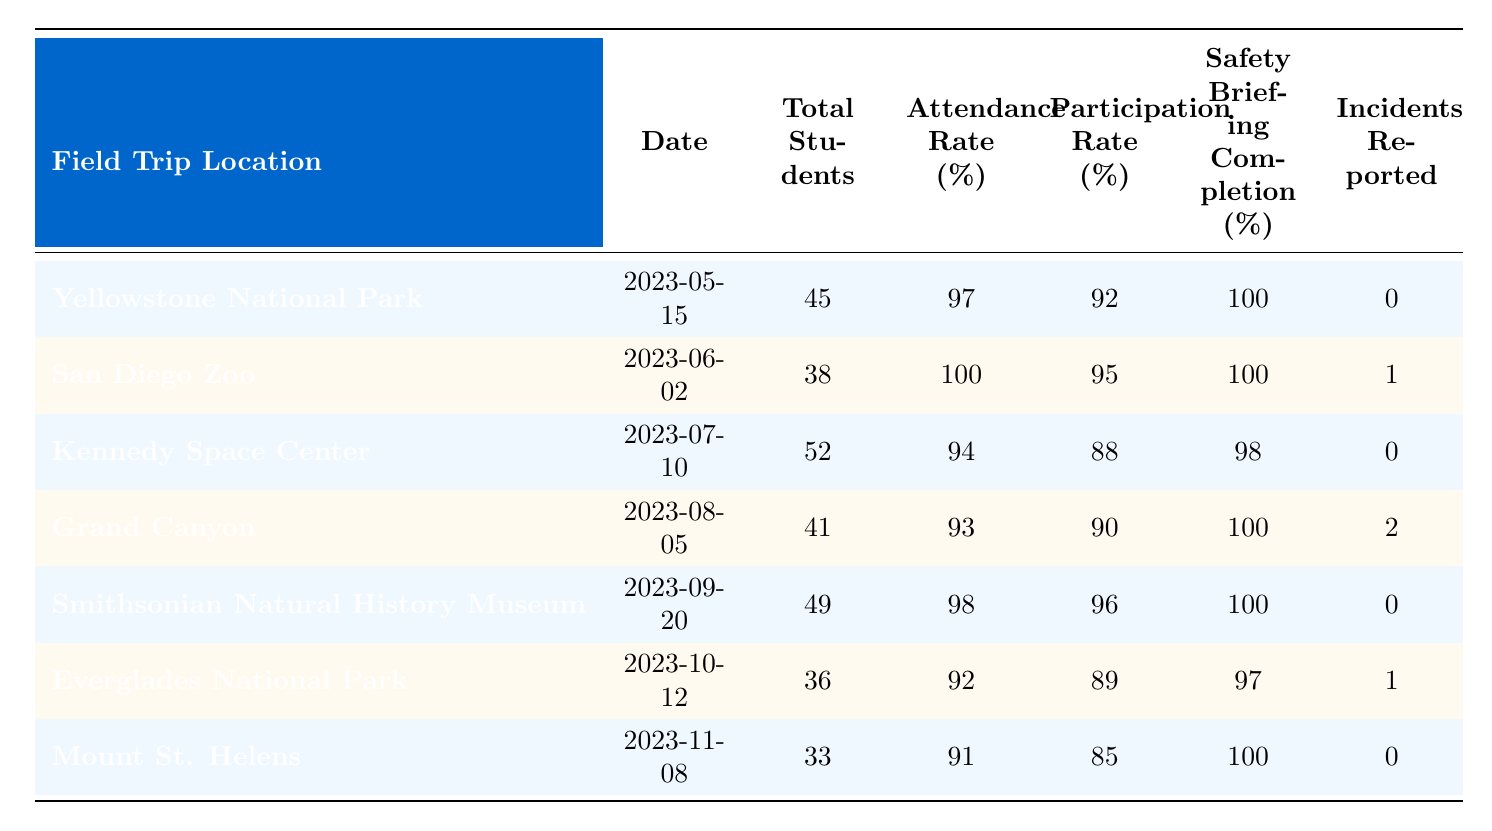What was the attendance rate for the San Diego Zoo trip? The attendance rate for the San Diego Zoo trip can be found in the table under the "Attendance Rate (%)" column for the date "2023-06-02." The value is 100%.
Answer: 100% How many incidents were reported during the Grand Canyon field trip? The number of incidents reported during the Grand Canyon field trip is listed in the "Incidents Reported" column for the date "2023-08-05." The value is 2.
Answer: 2 What is the average participation rate for all field trips? To find the average participation rate, sum all participation rates (92 + 95 + 88 + 90 + 96 + 89 + 85 = 625) and divide by the total number of trips (7). Therefore, 625/7 = approximately 89.29.
Answer: 89.29 Did all students complete the safety briefing at Yellowstone National Park? The safety briefing completion percentage for Yellowstone National Park is 100%, which indicates that all students completed the briefing.
Answer: Yes Which field trip had the lowest attendance rate? By comparing the attendance rates from each trip (97, 100, 94, 93, 98, 92, 91), the lowest attendance rate is for the Everglades National Park at 92%.
Answer: 92% How many total students attended field trips that had an incident reported? The trips with incidents reported are the San Diego Zoo (38 students) and the Grand Canyon (41 students). The total is 38 + 41 = 79.
Answer: 79 What was the safety briefing completion percentage for the Kennedy Space Center trip? The safety briefing completion percentage for the Kennedy Space Center on "2023-07-10" is found in the corresponding column, which is 98%.
Answer: 98% Which field trip had the highest number of total students? The highest number of total students is listed for the Kennedy Space Center, with 52 students, which is more than any other trip.
Answer: 52 What is the difference in attendance rates between the lowest and highest recorded rates? The highest attendance rate is 100% (San Diego Zoo) and the lowest is 91% (Mount St. Helens). The difference is 100 - 91 = 9%.
Answer: 9% How many trips had a safety briefing completion rate of 100%? The trips with a 100% safety briefing completion rate are Yellowstone National Park, San Diego Zoo, and Smithsonian Natural History Museum, totaling 3 trips.
Answer: 3 